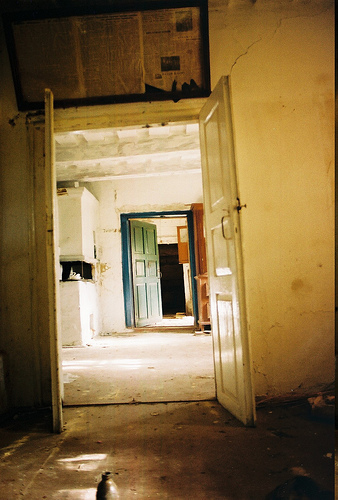<image>
Is the newspaper above the dust? Yes. The newspaper is positioned above the dust in the vertical space, higher up in the scene. 